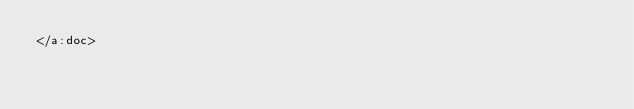Convert code to text. <code><loc_0><loc_0><loc_500><loc_500><_XML_></a:doc>
</code> 